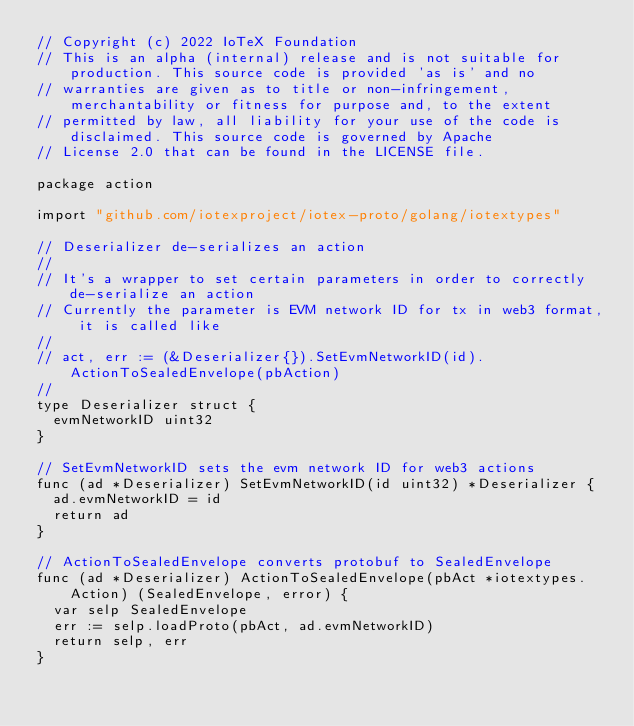Convert code to text. <code><loc_0><loc_0><loc_500><loc_500><_Go_>// Copyright (c) 2022 IoTeX Foundation
// This is an alpha (internal) release and is not suitable for production. This source code is provided 'as is' and no
// warranties are given as to title or non-infringement, merchantability or fitness for purpose and, to the extent
// permitted by law, all liability for your use of the code is disclaimed. This source code is governed by Apache
// License 2.0 that can be found in the LICENSE file.

package action

import "github.com/iotexproject/iotex-proto/golang/iotextypes"

// Deserializer de-serializes an action
//
// It's a wrapper to set certain parameters in order to correctly de-serialize an action
// Currently the parameter is EVM network ID for tx in web3 format, it is called like
//
// act, err := (&Deserializer{}).SetEvmNetworkID(id).ActionToSealedEnvelope(pbAction)
//
type Deserializer struct {
	evmNetworkID uint32
}

// SetEvmNetworkID sets the evm network ID for web3 actions
func (ad *Deserializer) SetEvmNetworkID(id uint32) *Deserializer {
	ad.evmNetworkID = id
	return ad
}

// ActionToSealedEnvelope converts protobuf to SealedEnvelope
func (ad *Deserializer) ActionToSealedEnvelope(pbAct *iotextypes.Action) (SealedEnvelope, error) {
	var selp SealedEnvelope
	err := selp.loadProto(pbAct, ad.evmNetworkID)
	return selp, err
}
</code> 